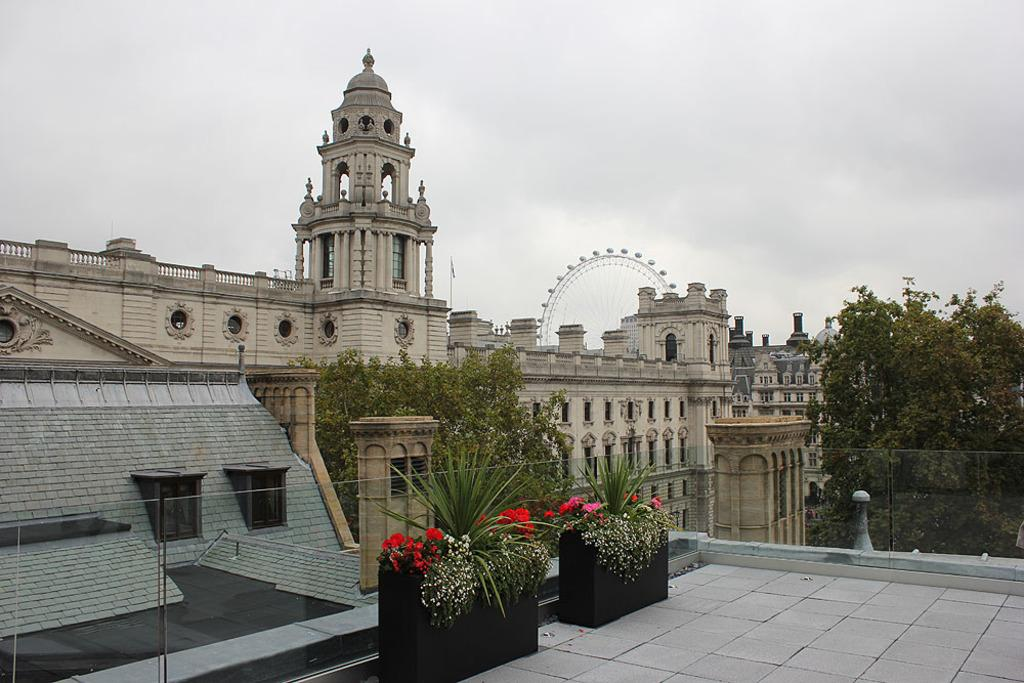What type of structures can be seen in the image? There are buildings in the image. What other natural elements are present in the image? There are trees in the image. What decorative elements can be seen in front of the buildings? There are flowers and plants in front of the buildings. What is the most prominent feature in the background of the image? There is a giant wall in the background of the image. How many lizards can be seen climbing on the buildings in the image? There are no lizards present in the image. What type of air is visible in the image? The image does not depict any specific type of air; it simply shows the buildings, trees, flowers and plants, and the giant wall. 